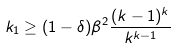<formula> <loc_0><loc_0><loc_500><loc_500>k _ { 1 } \geq ( 1 - \delta ) \beta ^ { 2 } \frac { ( k - 1 ) ^ { k } } { k ^ { k - 1 } }</formula> 